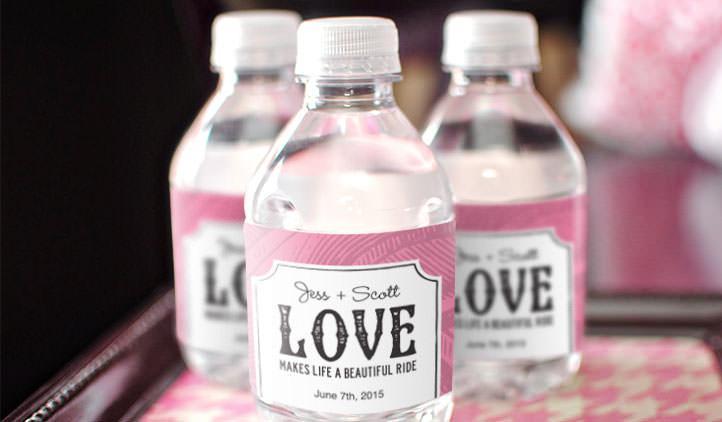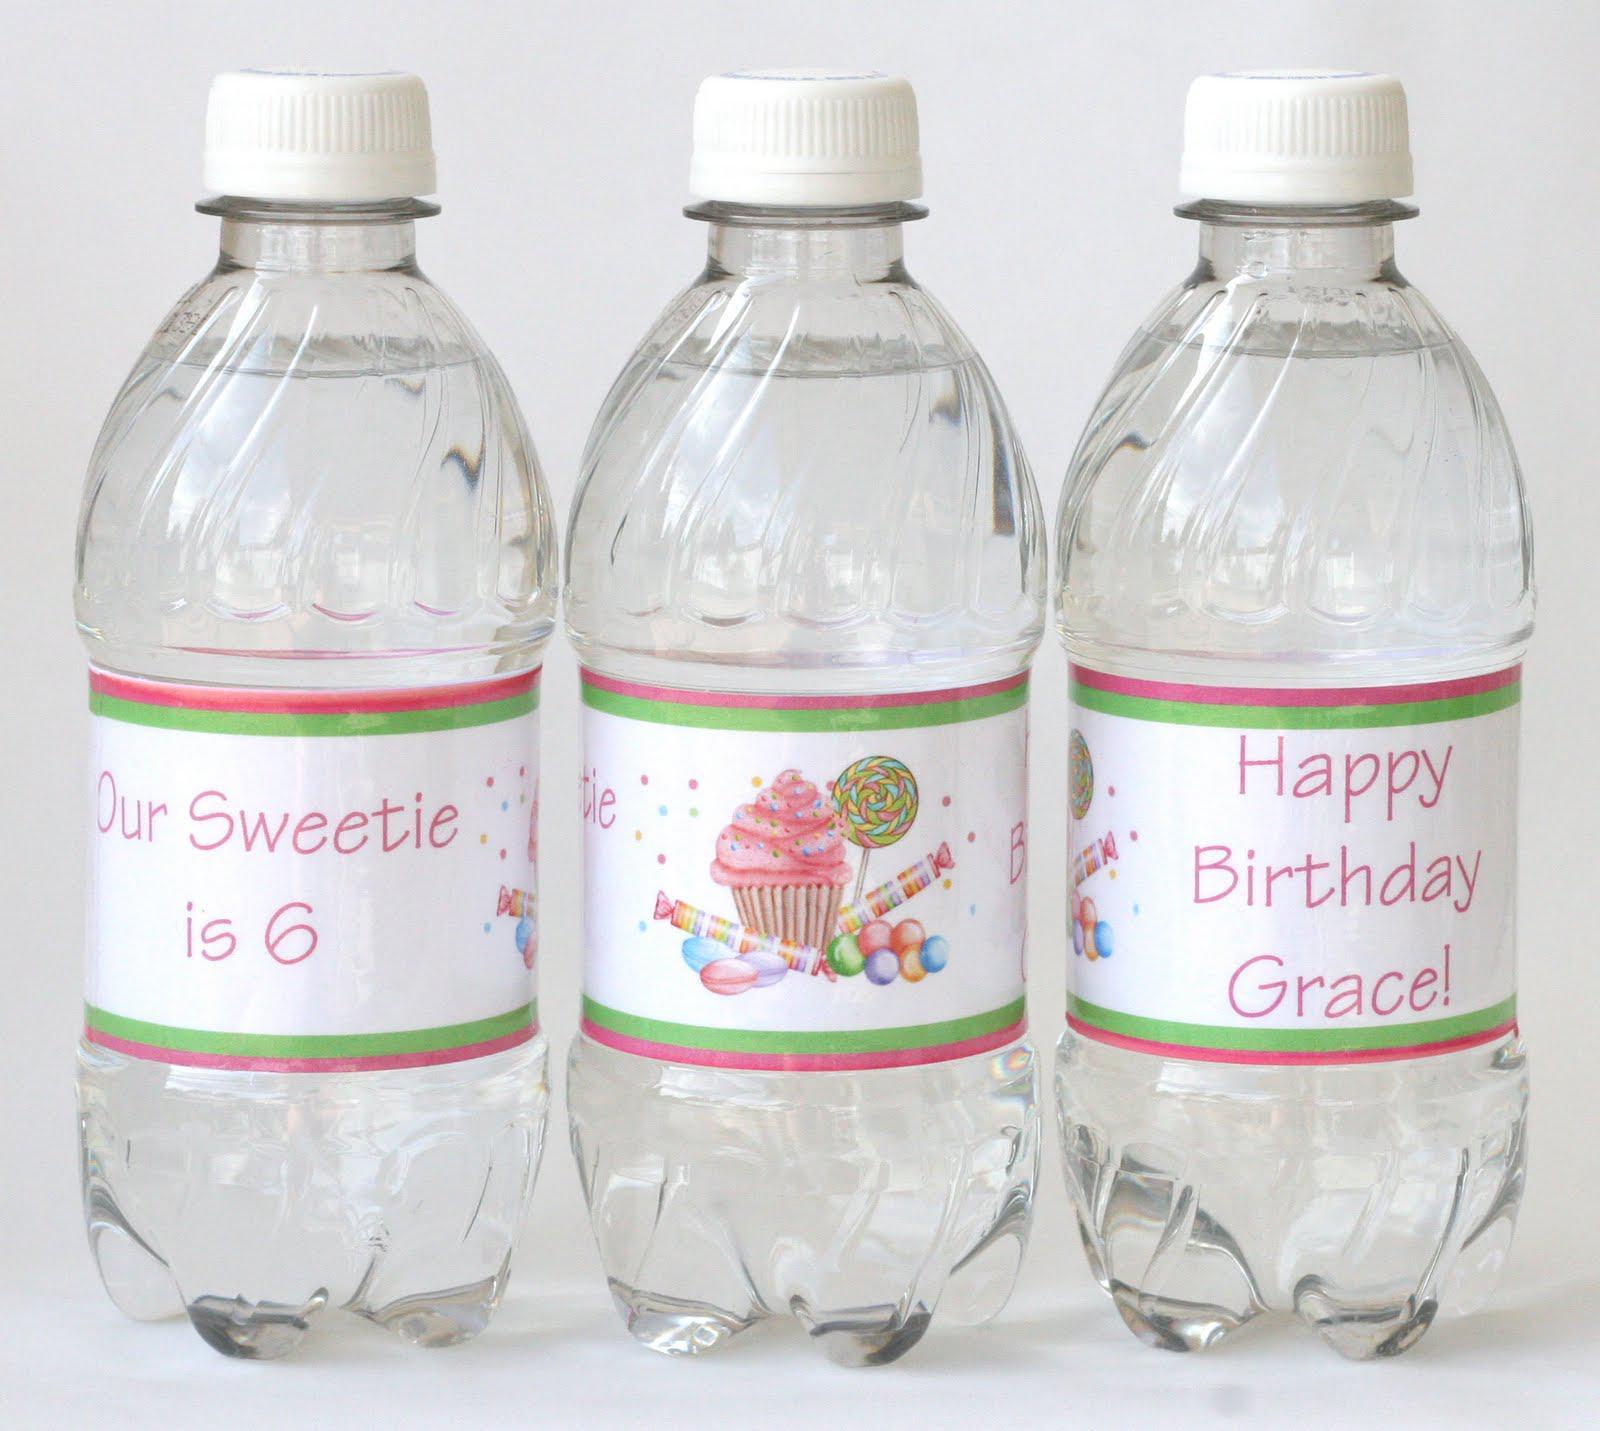The first image is the image on the left, the second image is the image on the right. Considering the images on both sides, is "There are less than eight disposable plastic water bottles" valid? Answer yes or no. Yes. The first image is the image on the left, the second image is the image on the right. Assess this claim about the two images: "There are two more bottles in one of the images than in the other.". Correct or not? Answer yes or no. No. 